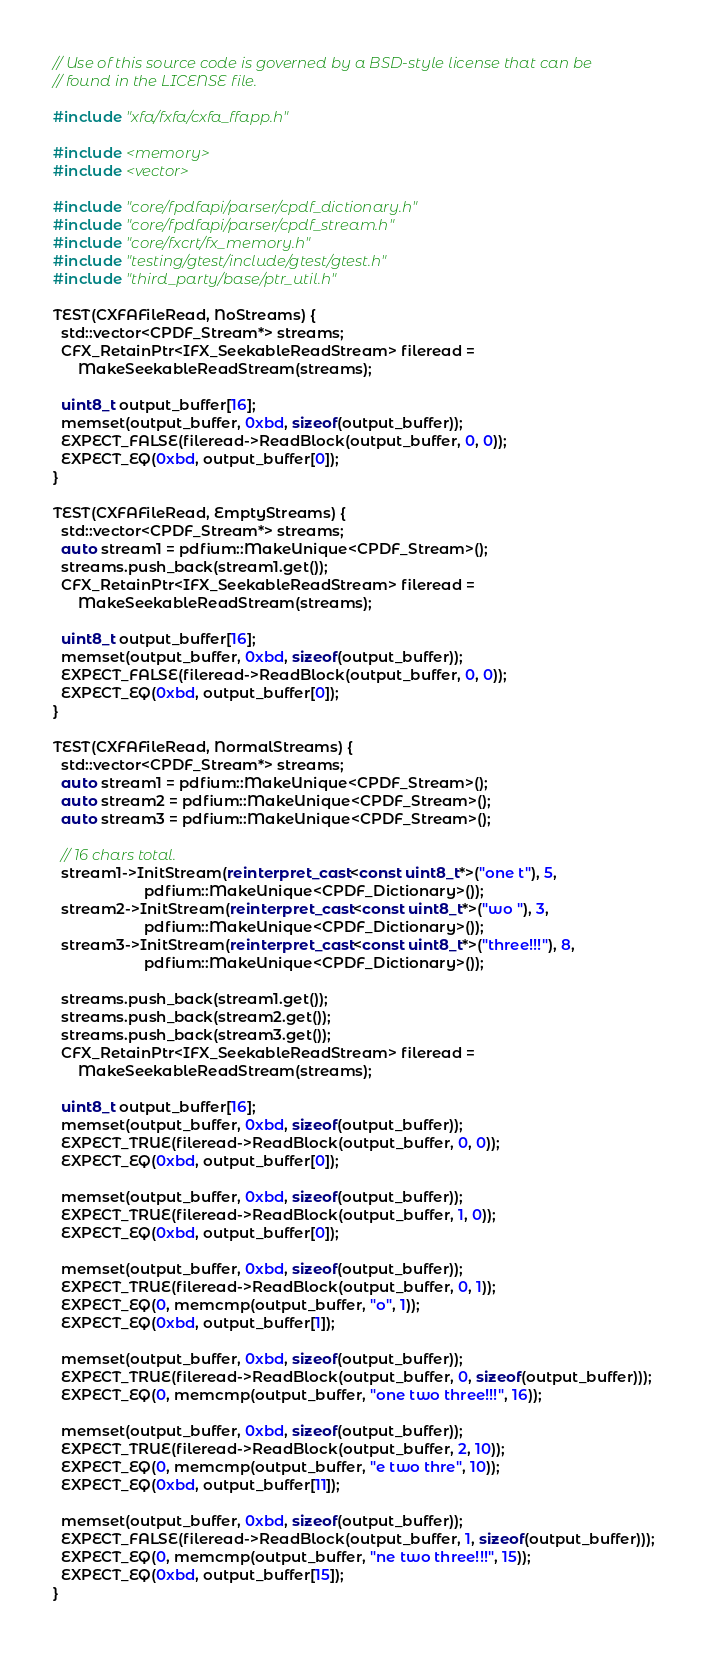Convert code to text. <code><loc_0><loc_0><loc_500><loc_500><_C++_>// Use of this source code is governed by a BSD-style license that can be
// found in the LICENSE file.

#include "xfa/fxfa/cxfa_ffapp.h"

#include <memory>
#include <vector>

#include "core/fpdfapi/parser/cpdf_dictionary.h"
#include "core/fpdfapi/parser/cpdf_stream.h"
#include "core/fxcrt/fx_memory.h"
#include "testing/gtest/include/gtest/gtest.h"
#include "third_party/base/ptr_util.h"

TEST(CXFAFileRead, NoStreams) {
  std::vector<CPDF_Stream*> streams;
  CFX_RetainPtr<IFX_SeekableReadStream> fileread =
      MakeSeekableReadStream(streams);

  uint8_t output_buffer[16];
  memset(output_buffer, 0xbd, sizeof(output_buffer));
  EXPECT_FALSE(fileread->ReadBlock(output_buffer, 0, 0));
  EXPECT_EQ(0xbd, output_buffer[0]);
}

TEST(CXFAFileRead, EmptyStreams) {
  std::vector<CPDF_Stream*> streams;
  auto stream1 = pdfium::MakeUnique<CPDF_Stream>();
  streams.push_back(stream1.get());
  CFX_RetainPtr<IFX_SeekableReadStream> fileread =
      MakeSeekableReadStream(streams);

  uint8_t output_buffer[16];
  memset(output_buffer, 0xbd, sizeof(output_buffer));
  EXPECT_FALSE(fileread->ReadBlock(output_buffer, 0, 0));
  EXPECT_EQ(0xbd, output_buffer[0]);
}

TEST(CXFAFileRead, NormalStreams) {
  std::vector<CPDF_Stream*> streams;
  auto stream1 = pdfium::MakeUnique<CPDF_Stream>();
  auto stream2 = pdfium::MakeUnique<CPDF_Stream>();
  auto stream3 = pdfium::MakeUnique<CPDF_Stream>();

  // 16 chars total.
  stream1->InitStream(reinterpret_cast<const uint8_t*>("one t"), 5,
                      pdfium::MakeUnique<CPDF_Dictionary>());
  stream2->InitStream(reinterpret_cast<const uint8_t*>("wo "), 3,
                      pdfium::MakeUnique<CPDF_Dictionary>());
  stream3->InitStream(reinterpret_cast<const uint8_t*>("three!!!"), 8,
                      pdfium::MakeUnique<CPDF_Dictionary>());

  streams.push_back(stream1.get());
  streams.push_back(stream2.get());
  streams.push_back(stream3.get());
  CFX_RetainPtr<IFX_SeekableReadStream> fileread =
      MakeSeekableReadStream(streams);

  uint8_t output_buffer[16];
  memset(output_buffer, 0xbd, sizeof(output_buffer));
  EXPECT_TRUE(fileread->ReadBlock(output_buffer, 0, 0));
  EXPECT_EQ(0xbd, output_buffer[0]);

  memset(output_buffer, 0xbd, sizeof(output_buffer));
  EXPECT_TRUE(fileread->ReadBlock(output_buffer, 1, 0));
  EXPECT_EQ(0xbd, output_buffer[0]);

  memset(output_buffer, 0xbd, sizeof(output_buffer));
  EXPECT_TRUE(fileread->ReadBlock(output_buffer, 0, 1));
  EXPECT_EQ(0, memcmp(output_buffer, "o", 1));
  EXPECT_EQ(0xbd, output_buffer[1]);

  memset(output_buffer, 0xbd, sizeof(output_buffer));
  EXPECT_TRUE(fileread->ReadBlock(output_buffer, 0, sizeof(output_buffer)));
  EXPECT_EQ(0, memcmp(output_buffer, "one two three!!!", 16));

  memset(output_buffer, 0xbd, sizeof(output_buffer));
  EXPECT_TRUE(fileread->ReadBlock(output_buffer, 2, 10));
  EXPECT_EQ(0, memcmp(output_buffer, "e two thre", 10));
  EXPECT_EQ(0xbd, output_buffer[11]);

  memset(output_buffer, 0xbd, sizeof(output_buffer));
  EXPECT_FALSE(fileread->ReadBlock(output_buffer, 1, sizeof(output_buffer)));
  EXPECT_EQ(0, memcmp(output_buffer, "ne two three!!!", 15));
  EXPECT_EQ(0xbd, output_buffer[15]);
}
</code> 